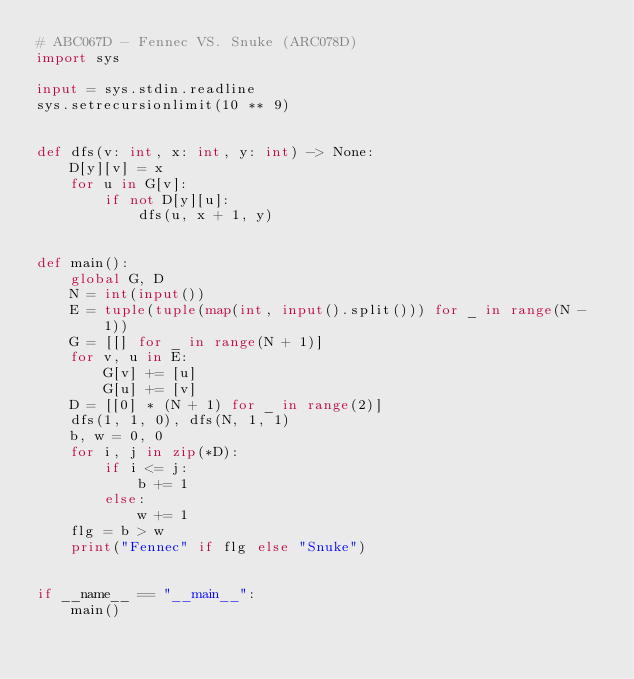<code> <loc_0><loc_0><loc_500><loc_500><_Python_># ABC067D - Fennec VS. Snuke (ARC078D)
import sys

input = sys.stdin.readline
sys.setrecursionlimit(10 ** 9)


def dfs(v: int, x: int, y: int) -> None:
    D[y][v] = x
    for u in G[v]:
        if not D[y][u]:
            dfs(u, x + 1, y)


def main():
    global G, D
    N = int(input())
    E = tuple(tuple(map(int, input().split())) for _ in range(N - 1))
    G = [[] for _ in range(N + 1)]
    for v, u in E:
        G[v] += [u]
        G[u] += [v]
    D = [[0] * (N + 1) for _ in range(2)]
    dfs(1, 1, 0), dfs(N, 1, 1)
    b, w = 0, 0
    for i, j in zip(*D):
        if i <= j:
            b += 1
        else:
            w += 1
    flg = b > w
    print("Fennec" if flg else "Snuke")


if __name__ == "__main__":
    main()</code> 